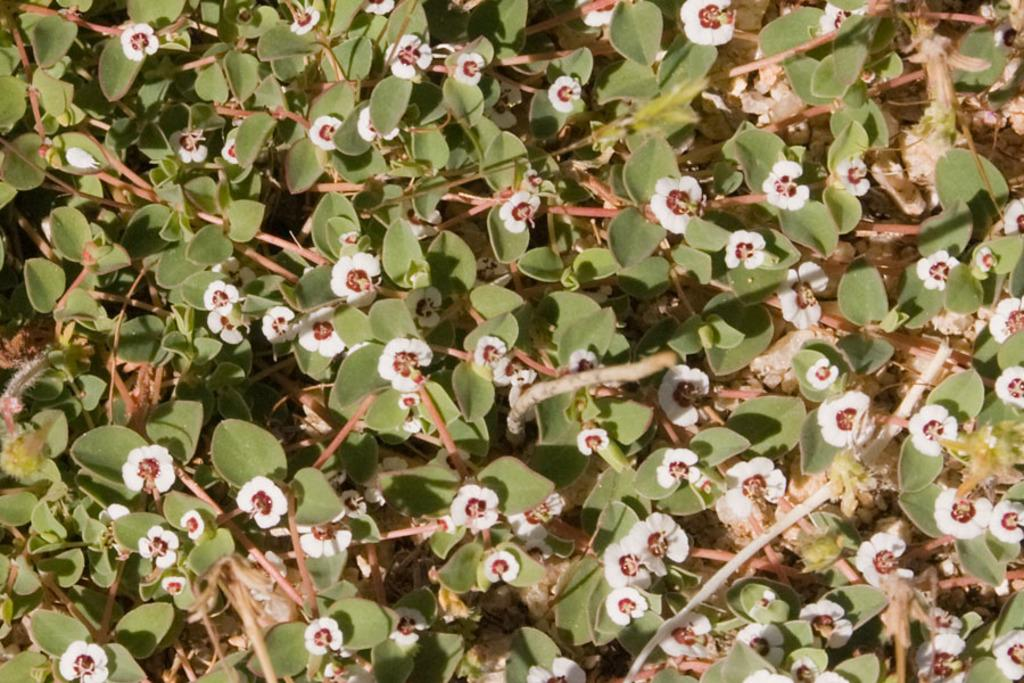What type of living organisms can be seen in the image? Plants can be seen in the image. What specific features do the plants have? The plants have flowers. What color are the flowers on the plants? The flowers are white in color. What type of holiday is being celebrated by the tiger in the image? There is no tiger present in the image, and therefore no holiday celebration can be observed. 